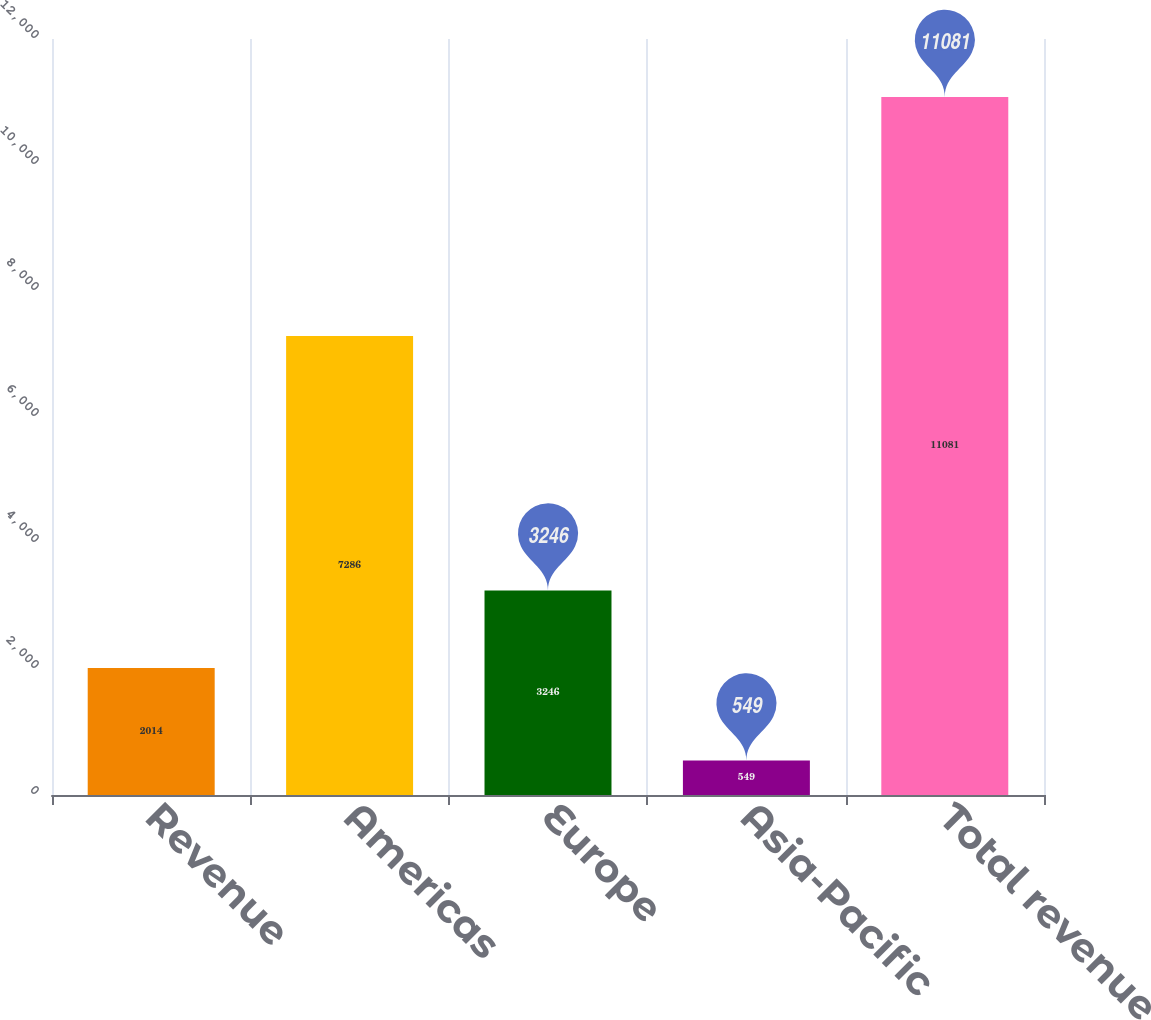Convert chart. <chart><loc_0><loc_0><loc_500><loc_500><bar_chart><fcel>Revenue<fcel>Americas<fcel>Europe<fcel>Asia-Pacific<fcel>Total revenue<nl><fcel>2014<fcel>7286<fcel>3246<fcel>549<fcel>11081<nl></chart> 